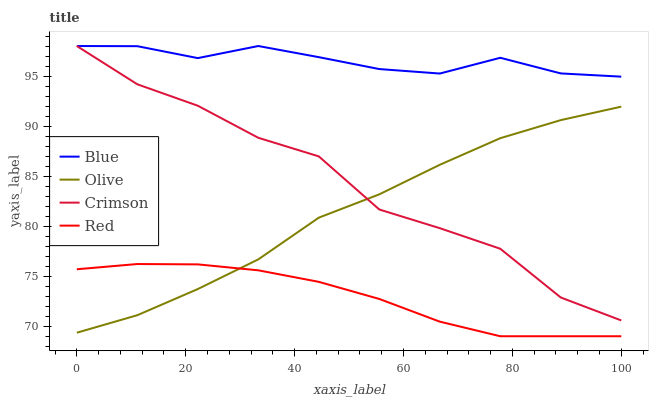Does Red have the minimum area under the curve?
Answer yes or no. Yes. Does Blue have the maximum area under the curve?
Answer yes or no. Yes. Does Olive have the minimum area under the curve?
Answer yes or no. No. Does Olive have the maximum area under the curve?
Answer yes or no. No. Is Red the smoothest?
Answer yes or no. Yes. Is Crimson the roughest?
Answer yes or no. Yes. Is Olive the smoothest?
Answer yes or no. No. Is Olive the roughest?
Answer yes or no. No. Does Red have the lowest value?
Answer yes or no. Yes. Does Olive have the lowest value?
Answer yes or no. No. Does Crimson have the highest value?
Answer yes or no. Yes. Does Olive have the highest value?
Answer yes or no. No. Is Olive less than Blue?
Answer yes or no. Yes. Is Blue greater than Olive?
Answer yes or no. Yes. Does Olive intersect Red?
Answer yes or no. Yes. Is Olive less than Red?
Answer yes or no. No. Is Olive greater than Red?
Answer yes or no. No. Does Olive intersect Blue?
Answer yes or no. No. 